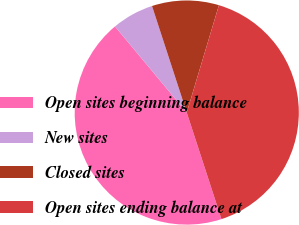<chart> <loc_0><loc_0><loc_500><loc_500><pie_chart><fcel>Open sites beginning balance<fcel>New sites<fcel>Closed sites<fcel>Open sites ending balance at<nl><fcel>43.96%<fcel>6.04%<fcel>9.65%<fcel>40.35%<nl></chart> 